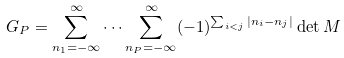<formula> <loc_0><loc_0><loc_500><loc_500>G _ { P } = \sum _ { n _ { 1 } = - \infty } ^ { \infty } \dots \sum _ { n _ { P } = - \infty } ^ { \infty } ( - 1 ) ^ { \sum _ { i < j } | n _ { i } - n _ { j } | } \det { M }</formula> 